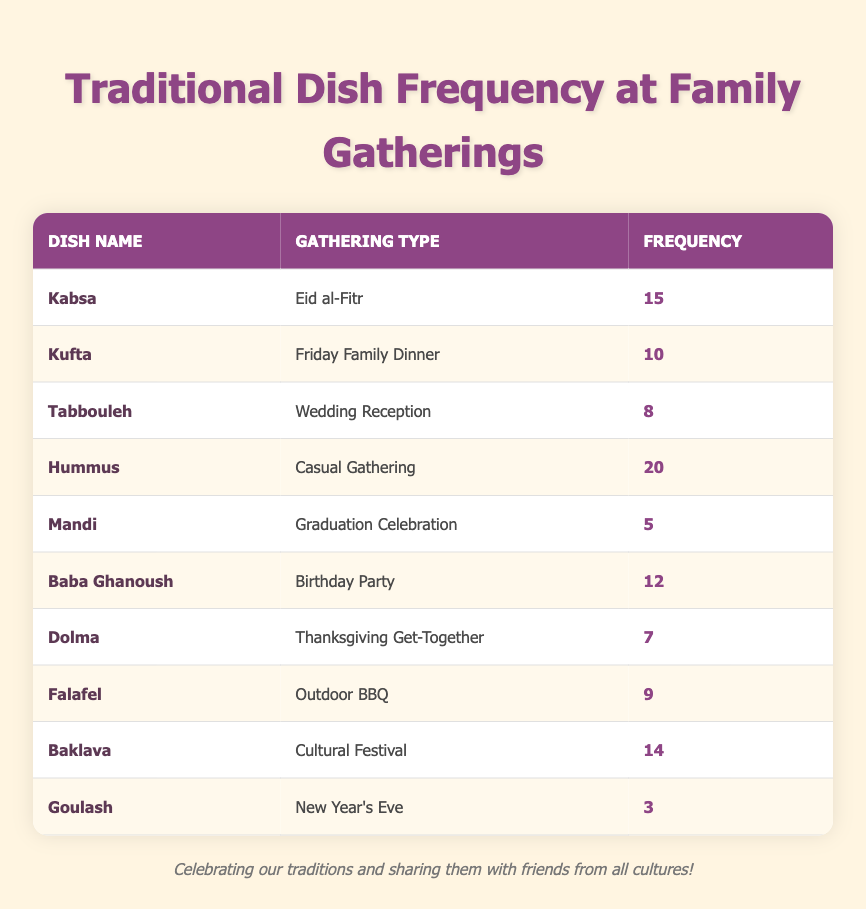What is the frequency of Kabsa during Eid al-Fitr? From the table, we can see that the dish Kabsa has a frequency of 15 prepared for the gathering type of Eid al-Fitr.
Answer: 15 Which dish is prepared most frequently at Casual Gatherings? The dish Hummus has the highest frequency of 20 at Casual Gatherings, as indicated in the table.
Answer: Hummus How many dishes are prepared more than 10 times across all gatherings? By analyzing the table, we find that Kabsa (15), Hummus (20), Baba Ghanoush (12), and Baklava (14) are prepared more than 10 times. In total, there are 4 such dishes.
Answer: 4 Is Baklava prepared more frequently than Dolma? Yes, Baklava has a frequency of 14, while Dolma only has a frequency of 7, so Baklava is prepared more frequently.
Answer: Yes What is the total frequency of dishes prepared for Thanksgiving Get-Together? The table indicates that only one dish, Dolma, is served for Thanksgiving Get-Together with a frequency of 7. Therefore, the total frequency is 7.
Answer: 7 What is the dish with the lowest frequency, and how often is it prepared? The dish with the lowest frequency is Goulash, which is prepared only 3 times for New Year's Eve, as shown in the table.
Answer: Goulash, 3 What is the average frequency of all the dishes prepared for family gatherings? To find the average, we first sum all frequencies: 15 + 10 + 8 + 20 + 5 + 12 + 7 + 9 + 14 + 3 = 93. There are 10 dishes in total, so the average frequency is 93/10 = 9.3.
Answer: 9.3 Which gathering had the maximum frequency of dish preparation? Hummus at Casual Gathering had the highest frequency of 20, which is the maximum value in the table across all gatherings.
Answer: Casual Gathering Are there any dishes that are prepared only once for any gathering? No, all dishes listed in the table have been prepared multiple times, indicating that no dish has a frequency of 1.
Answer: No 